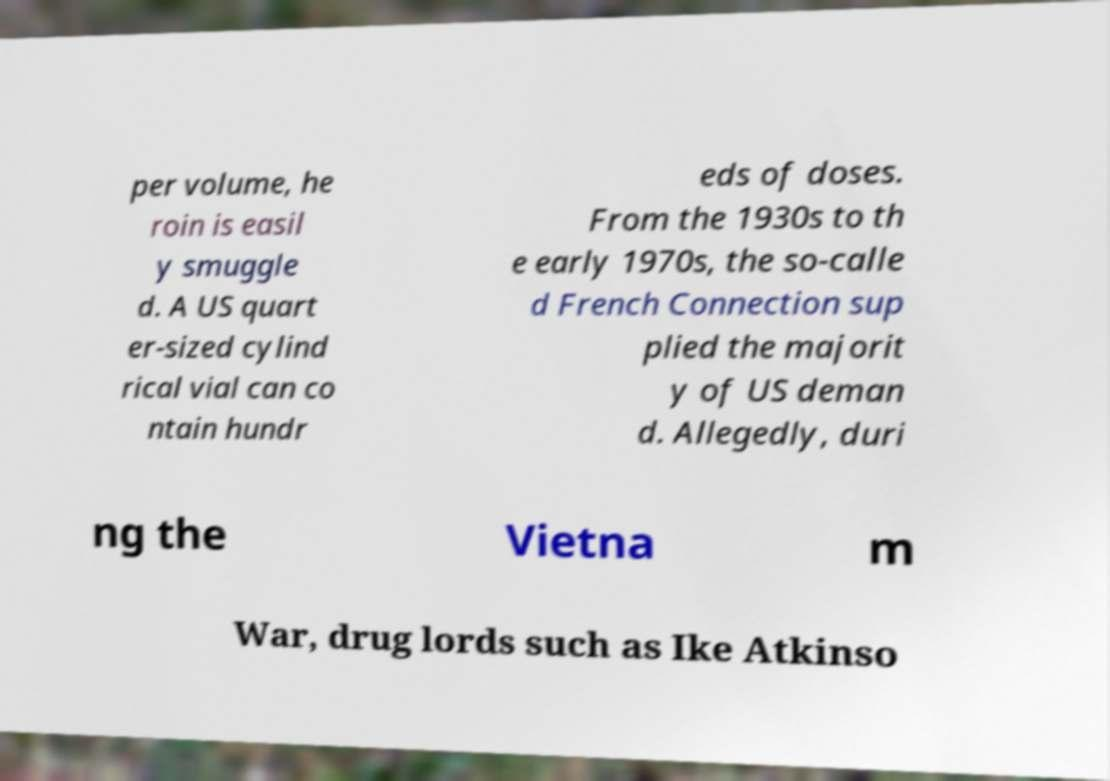Can you read and provide the text displayed in the image?This photo seems to have some interesting text. Can you extract and type it out for me? per volume, he roin is easil y smuggle d. A US quart er-sized cylind rical vial can co ntain hundr eds of doses. From the 1930s to th e early 1970s, the so-calle d French Connection sup plied the majorit y of US deman d. Allegedly, duri ng the Vietna m War, drug lords such as Ike Atkinso 